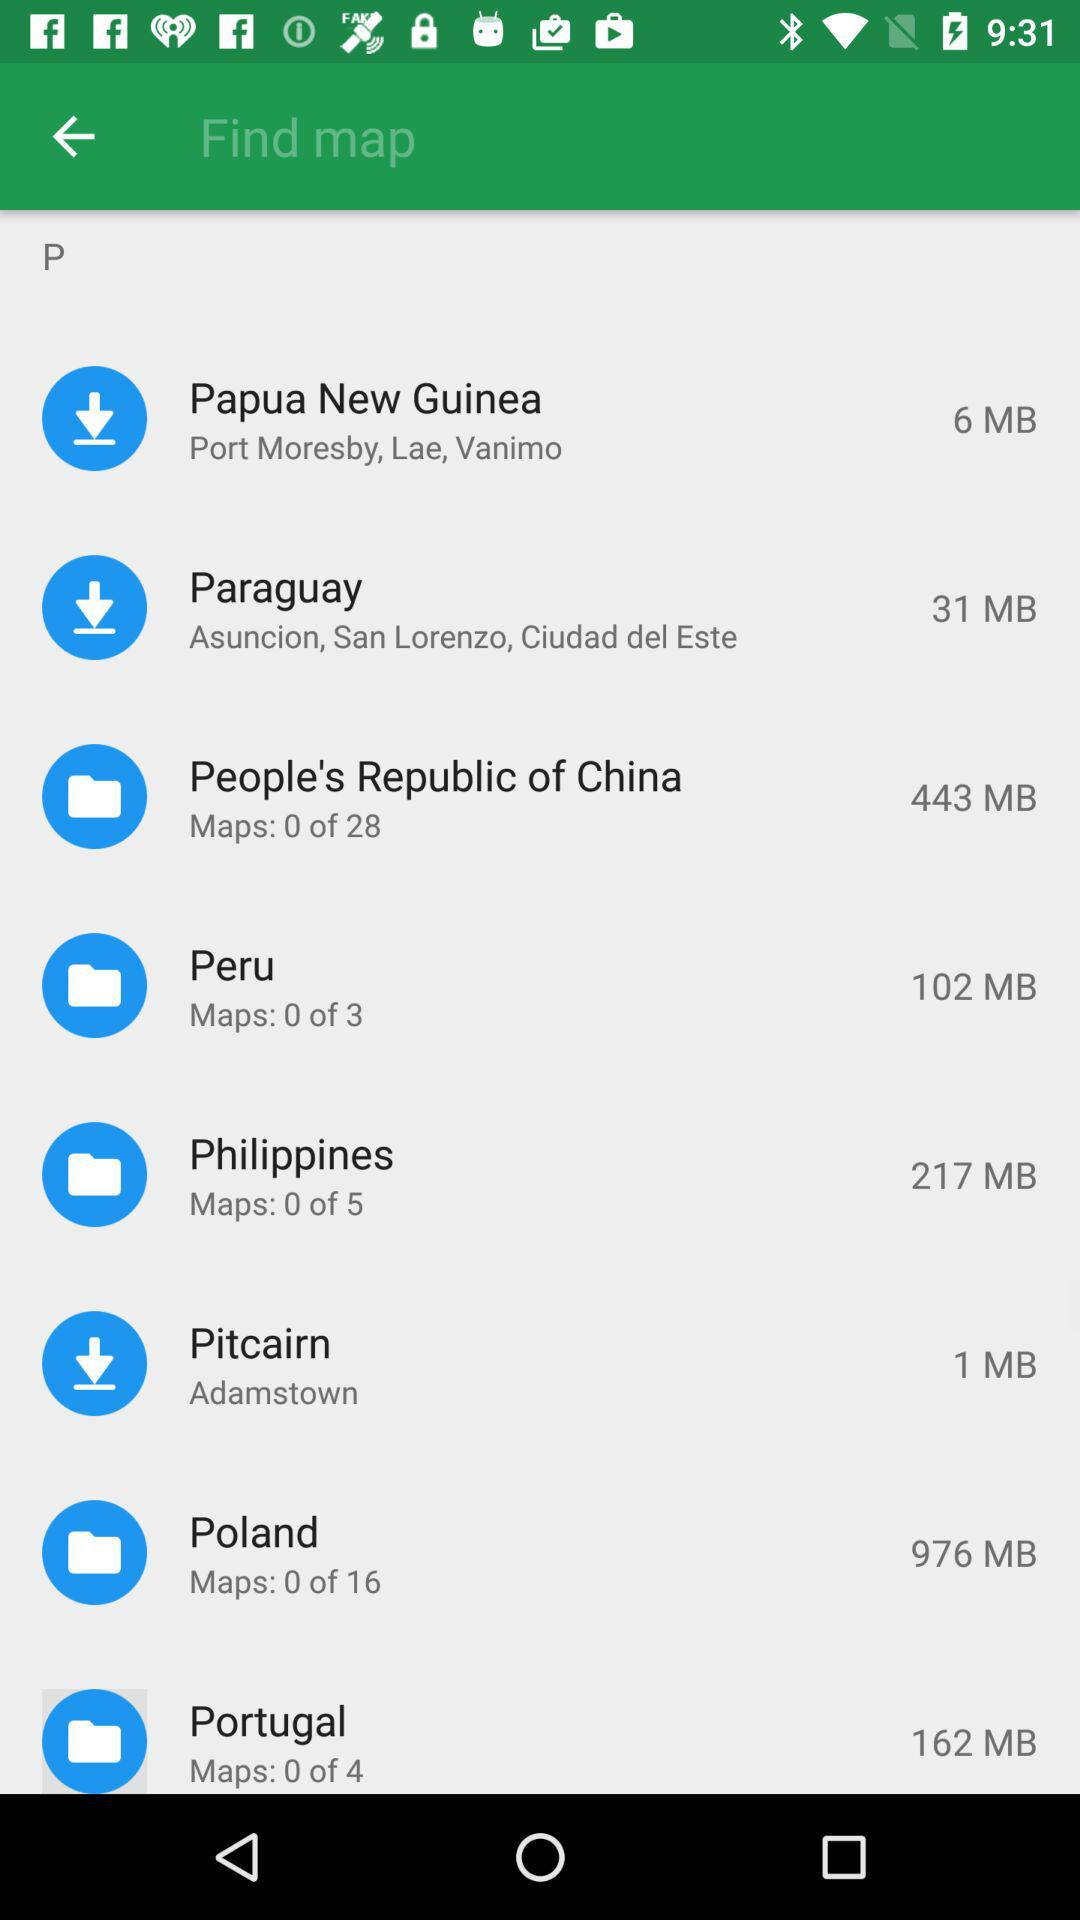How many maps does Peru have?
Answer the question using a single word or phrase. 3 